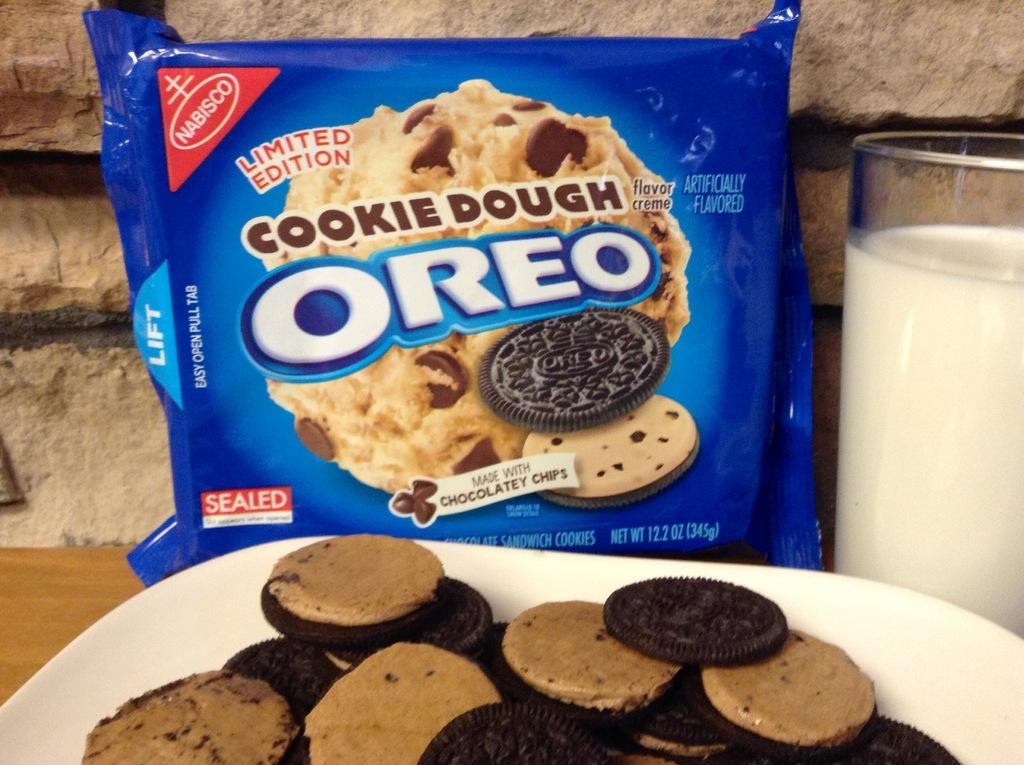What type of food item is in the packet in the image? There is no specific information about the type of food in the packet. What liquid is present in the image? There is milk in the image. What is used for holding the milk? There is a glass in the image. What is used for holding the biscuits? There is a plate in the image. What type of biscuits are on the plate? There are biscuits and cream biscuits in the plate. What is the surface made of that the glass and plate are placed on? There is a wooden surface in the image. What type of oil is being applied to the skin in the image? There is no oil or skin present in the image. What wish is being granted in the image? There is no indication of a wish being granted in the image. 